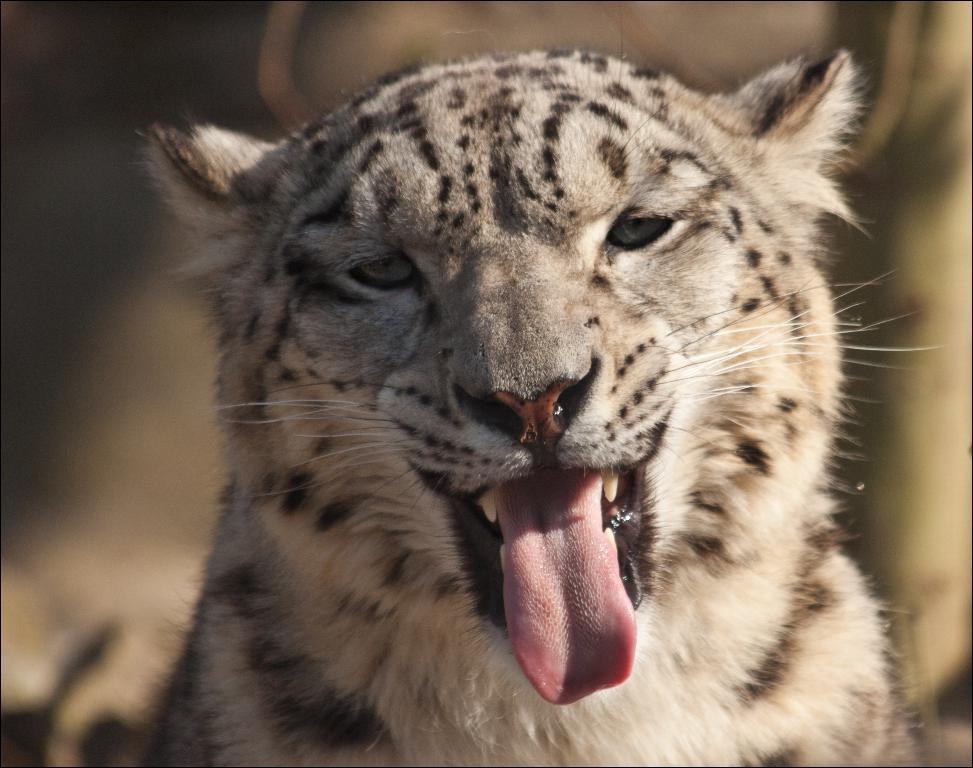How would you summarize this image in a sentence or two? In this image we can see a tiger. The background of the image is blur. 